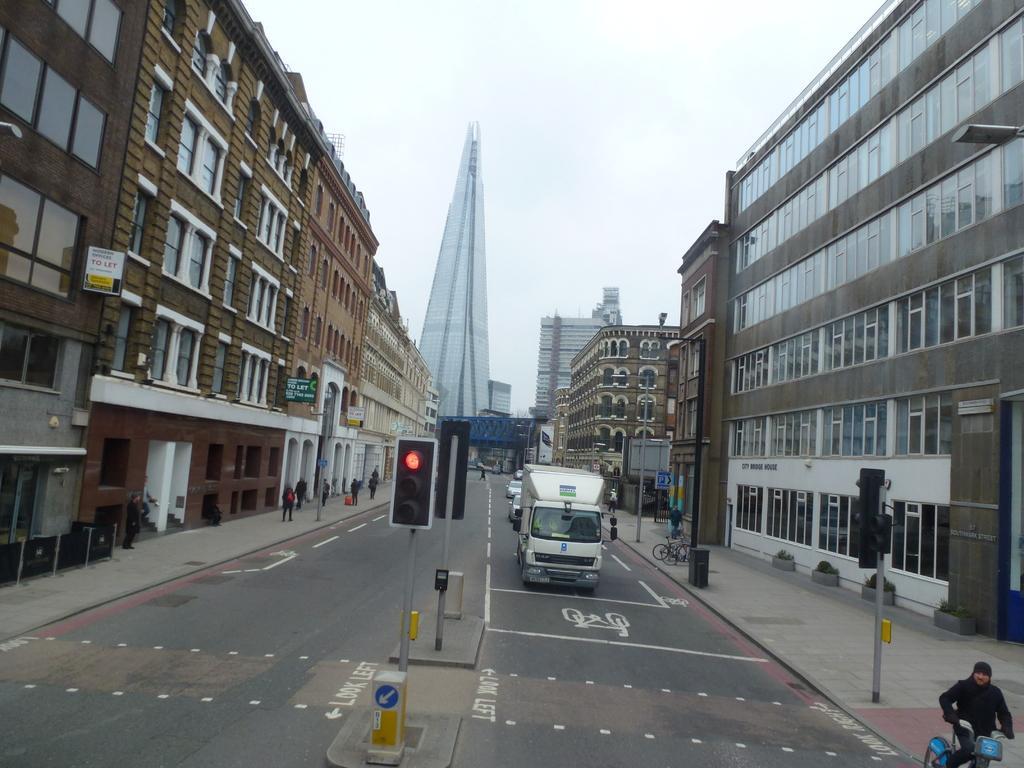Describe this image in one or two sentences. In the picture we can see a road with a white stripe and a truck behind it, we can see some vehicles and in the middle of the road we can see a pole with traffic lights and on the either sides of the road we can see buildings with windows and glasses to it and in the background we can see a painted building and behind it we can see a sky. 